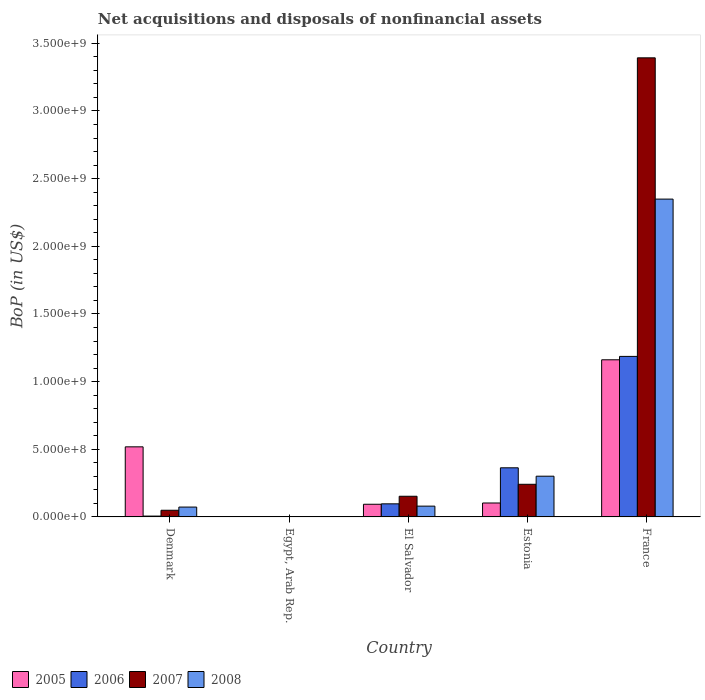Are the number of bars on each tick of the X-axis equal?
Keep it short and to the point. No. How many bars are there on the 5th tick from the left?
Your answer should be very brief. 4. How many bars are there on the 2nd tick from the right?
Offer a very short reply. 4. What is the label of the 3rd group of bars from the left?
Your answer should be compact. El Salvador. In how many cases, is the number of bars for a given country not equal to the number of legend labels?
Provide a short and direct response. 1. What is the Balance of Payments in 2005 in France?
Make the answer very short. 1.16e+09. Across all countries, what is the maximum Balance of Payments in 2007?
Offer a terse response. 3.39e+09. In which country was the Balance of Payments in 2006 maximum?
Give a very brief answer. France. What is the total Balance of Payments in 2006 in the graph?
Ensure brevity in your answer.  1.65e+09. What is the difference between the Balance of Payments in 2006 in Denmark and that in El Salvador?
Offer a very short reply. -9.05e+07. What is the difference between the Balance of Payments in 2005 in France and the Balance of Payments in 2007 in Egypt, Arab Rep.?
Your response must be concise. 1.16e+09. What is the average Balance of Payments in 2005 per country?
Provide a succinct answer. 3.75e+08. What is the difference between the Balance of Payments of/in 2008 and Balance of Payments of/in 2006 in France?
Make the answer very short. 1.16e+09. In how many countries, is the Balance of Payments in 2007 greater than 1900000000 US$?
Your response must be concise. 1. What is the ratio of the Balance of Payments in 2008 in El Salvador to that in Estonia?
Offer a terse response. 0.27. Is the Balance of Payments in 2006 in El Salvador less than that in France?
Ensure brevity in your answer.  Yes. Is the difference between the Balance of Payments in 2008 in Denmark and El Salvador greater than the difference between the Balance of Payments in 2006 in Denmark and El Salvador?
Your response must be concise. Yes. What is the difference between the highest and the second highest Balance of Payments in 2007?
Give a very brief answer. -3.24e+09. What is the difference between the highest and the lowest Balance of Payments in 2006?
Keep it short and to the point. 1.19e+09. In how many countries, is the Balance of Payments in 2008 greater than the average Balance of Payments in 2008 taken over all countries?
Make the answer very short. 1. Is the sum of the Balance of Payments in 2007 in Egypt, Arab Rep. and Estonia greater than the maximum Balance of Payments in 2005 across all countries?
Make the answer very short. No. Is it the case that in every country, the sum of the Balance of Payments in 2005 and Balance of Payments in 2006 is greater than the Balance of Payments in 2008?
Make the answer very short. No. Are all the bars in the graph horizontal?
Your answer should be very brief. No. How many countries are there in the graph?
Keep it short and to the point. 5. What is the difference between two consecutive major ticks on the Y-axis?
Provide a succinct answer. 5.00e+08. Where does the legend appear in the graph?
Your response must be concise. Bottom left. How many legend labels are there?
Provide a short and direct response. 4. What is the title of the graph?
Give a very brief answer. Net acquisitions and disposals of nonfinancial assets. What is the label or title of the X-axis?
Your answer should be very brief. Country. What is the label or title of the Y-axis?
Your answer should be compact. BoP (in US$). What is the BoP (in US$) in 2005 in Denmark?
Make the answer very short. 5.18e+08. What is the BoP (in US$) in 2006 in Denmark?
Make the answer very short. 6.28e+06. What is the BoP (in US$) of 2007 in Denmark?
Your answer should be compact. 4.93e+07. What is the BoP (in US$) in 2008 in Denmark?
Your answer should be compact. 7.29e+07. What is the BoP (in US$) in 2005 in Egypt, Arab Rep.?
Ensure brevity in your answer.  0. What is the BoP (in US$) in 2007 in Egypt, Arab Rep.?
Provide a succinct answer. 1.90e+06. What is the BoP (in US$) in 2005 in El Salvador?
Your response must be concise. 9.36e+07. What is the BoP (in US$) in 2006 in El Salvador?
Ensure brevity in your answer.  9.68e+07. What is the BoP (in US$) of 2007 in El Salvador?
Give a very brief answer. 1.53e+08. What is the BoP (in US$) of 2008 in El Salvador?
Provide a short and direct response. 7.98e+07. What is the BoP (in US$) in 2005 in Estonia?
Offer a terse response. 1.03e+08. What is the BoP (in US$) in 2006 in Estonia?
Provide a short and direct response. 3.63e+08. What is the BoP (in US$) in 2007 in Estonia?
Keep it short and to the point. 2.41e+08. What is the BoP (in US$) of 2008 in Estonia?
Your answer should be compact. 3.01e+08. What is the BoP (in US$) of 2005 in France?
Ensure brevity in your answer.  1.16e+09. What is the BoP (in US$) in 2006 in France?
Your response must be concise. 1.19e+09. What is the BoP (in US$) of 2007 in France?
Provide a succinct answer. 3.39e+09. What is the BoP (in US$) in 2008 in France?
Ensure brevity in your answer.  2.35e+09. Across all countries, what is the maximum BoP (in US$) of 2005?
Ensure brevity in your answer.  1.16e+09. Across all countries, what is the maximum BoP (in US$) in 2006?
Ensure brevity in your answer.  1.19e+09. Across all countries, what is the maximum BoP (in US$) in 2007?
Your answer should be very brief. 3.39e+09. Across all countries, what is the maximum BoP (in US$) of 2008?
Your answer should be very brief. 2.35e+09. Across all countries, what is the minimum BoP (in US$) of 2005?
Your response must be concise. 0. Across all countries, what is the minimum BoP (in US$) in 2006?
Your response must be concise. 0. Across all countries, what is the minimum BoP (in US$) in 2007?
Your response must be concise. 1.90e+06. Across all countries, what is the minimum BoP (in US$) of 2008?
Give a very brief answer. 0. What is the total BoP (in US$) in 2005 in the graph?
Your answer should be very brief. 1.88e+09. What is the total BoP (in US$) in 2006 in the graph?
Give a very brief answer. 1.65e+09. What is the total BoP (in US$) in 2007 in the graph?
Make the answer very short. 3.84e+09. What is the total BoP (in US$) in 2008 in the graph?
Your response must be concise. 2.80e+09. What is the difference between the BoP (in US$) of 2007 in Denmark and that in Egypt, Arab Rep.?
Ensure brevity in your answer.  4.74e+07. What is the difference between the BoP (in US$) of 2005 in Denmark and that in El Salvador?
Keep it short and to the point. 4.24e+08. What is the difference between the BoP (in US$) in 2006 in Denmark and that in El Salvador?
Keep it short and to the point. -9.05e+07. What is the difference between the BoP (in US$) of 2007 in Denmark and that in El Salvador?
Offer a very short reply. -1.03e+08. What is the difference between the BoP (in US$) in 2008 in Denmark and that in El Salvador?
Your answer should be compact. -6.95e+06. What is the difference between the BoP (in US$) in 2005 in Denmark and that in Estonia?
Your response must be concise. 4.15e+08. What is the difference between the BoP (in US$) in 2006 in Denmark and that in Estonia?
Make the answer very short. -3.57e+08. What is the difference between the BoP (in US$) in 2007 in Denmark and that in Estonia?
Your answer should be very brief. -1.92e+08. What is the difference between the BoP (in US$) in 2008 in Denmark and that in Estonia?
Provide a succinct answer. -2.28e+08. What is the difference between the BoP (in US$) in 2005 in Denmark and that in France?
Give a very brief answer. -6.43e+08. What is the difference between the BoP (in US$) in 2006 in Denmark and that in France?
Offer a very short reply. -1.18e+09. What is the difference between the BoP (in US$) in 2007 in Denmark and that in France?
Offer a very short reply. -3.34e+09. What is the difference between the BoP (in US$) of 2008 in Denmark and that in France?
Offer a terse response. -2.28e+09. What is the difference between the BoP (in US$) of 2007 in Egypt, Arab Rep. and that in El Salvador?
Make the answer very short. -1.51e+08. What is the difference between the BoP (in US$) in 2007 in Egypt, Arab Rep. and that in Estonia?
Provide a succinct answer. -2.39e+08. What is the difference between the BoP (in US$) of 2007 in Egypt, Arab Rep. and that in France?
Ensure brevity in your answer.  -3.39e+09. What is the difference between the BoP (in US$) of 2005 in El Salvador and that in Estonia?
Ensure brevity in your answer.  -9.37e+06. What is the difference between the BoP (in US$) in 2006 in El Salvador and that in Estonia?
Give a very brief answer. -2.66e+08. What is the difference between the BoP (in US$) of 2007 in El Salvador and that in Estonia?
Make the answer very short. -8.84e+07. What is the difference between the BoP (in US$) in 2008 in El Salvador and that in Estonia?
Give a very brief answer. -2.21e+08. What is the difference between the BoP (in US$) of 2005 in El Salvador and that in France?
Provide a succinct answer. -1.07e+09. What is the difference between the BoP (in US$) in 2006 in El Salvador and that in France?
Make the answer very short. -1.09e+09. What is the difference between the BoP (in US$) of 2007 in El Salvador and that in France?
Keep it short and to the point. -3.24e+09. What is the difference between the BoP (in US$) in 2008 in El Salvador and that in France?
Provide a short and direct response. -2.27e+09. What is the difference between the BoP (in US$) of 2005 in Estonia and that in France?
Your answer should be very brief. -1.06e+09. What is the difference between the BoP (in US$) in 2006 in Estonia and that in France?
Ensure brevity in your answer.  -8.23e+08. What is the difference between the BoP (in US$) in 2007 in Estonia and that in France?
Make the answer very short. -3.15e+09. What is the difference between the BoP (in US$) in 2008 in Estonia and that in France?
Ensure brevity in your answer.  -2.05e+09. What is the difference between the BoP (in US$) of 2005 in Denmark and the BoP (in US$) of 2007 in Egypt, Arab Rep.?
Make the answer very short. 5.16e+08. What is the difference between the BoP (in US$) of 2006 in Denmark and the BoP (in US$) of 2007 in Egypt, Arab Rep.?
Your answer should be compact. 4.38e+06. What is the difference between the BoP (in US$) of 2005 in Denmark and the BoP (in US$) of 2006 in El Salvador?
Offer a very short reply. 4.21e+08. What is the difference between the BoP (in US$) of 2005 in Denmark and the BoP (in US$) of 2007 in El Salvador?
Provide a succinct answer. 3.65e+08. What is the difference between the BoP (in US$) in 2005 in Denmark and the BoP (in US$) in 2008 in El Salvador?
Your response must be concise. 4.38e+08. What is the difference between the BoP (in US$) in 2006 in Denmark and the BoP (in US$) in 2007 in El Salvador?
Provide a short and direct response. -1.47e+08. What is the difference between the BoP (in US$) of 2006 in Denmark and the BoP (in US$) of 2008 in El Salvador?
Provide a short and direct response. -7.35e+07. What is the difference between the BoP (in US$) of 2007 in Denmark and the BoP (in US$) of 2008 in El Salvador?
Offer a very short reply. -3.05e+07. What is the difference between the BoP (in US$) of 2005 in Denmark and the BoP (in US$) of 2006 in Estonia?
Offer a very short reply. 1.55e+08. What is the difference between the BoP (in US$) of 2005 in Denmark and the BoP (in US$) of 2007 in Estonia?
Your answer should be very brief. 2.77e+08. What is the difference between the BoP (in US$) of 2005 in Denmark and the BoP (in US$) of 2008 in Estonia?
Your answer should be compact. 2.17e+08. What is the difference between the BoP (in US$) in 2006 in Denmark and the BoP (in US$) in 2007 in Estonia?
Provide a succinct answer. -2.35e+08. What is the difference between the BoP (in US$) in 2006 in Denmark and the BoP (in US$) in 2008 in Estonia?
Your answer should be very brief. -2.95e+08. What is the difference between the BoP (in US$) of 2007 in Denmark and the BoP (in US$) of 2008 in Estonia?
Your response must be concise. -2.52e+08. What is the difference between the BoP (in US$) of 2005 in Denmark and the BoP (in US$) of 2006 in France?
Ensure brevity in your answer.  -6.68e+08. What is the difference between the BoP (in US$) in 2005 in Denmark and the BoP (in US$) in 2007 in France?
Give a very brief answer. -2.87e+09. What is the difference between the BoP (in US$) of 2005 in Denmark and the BoP (in US$) of 2008 in France?
Offer a terse response. -1.83e+09. What is the difference between the BoP (in US$) of 2006 in Denmark and the BoP (in US$) of 2007 in France?
Your response must be concise. -3.39e+09. What is the difference between the BoP (in US$) in 2006 in Denmark and the BoP (in US$) in 2008 in France?
Give a very brief answer. -2.34e+09. What is the difference between the BoP (in US$) of 2007 in Denmark and the BoP (in US$) of 2008 in France?
Provide a short and direct response. -2.30e+09. What is the difference between the BoP (in US$) of 2007 in Egypt, Arab Rep. and the BoP (in US$) of 2008 in El Salvador?
Offer a terse response. -7.79e+07. What is the difference between the BoP (in US$) of 2007 in Egypt, Arab Rep. and the BoP (in US$) of 2008 in Estonia?
Provide a short and direct response. -2.99e+08. What is the difference between the BoP (in US$) in 2007 in Egypt, Arab Rep. and the BoP (in US$) in 2008 in France?
Provide a succinct answer. -2.35e+09. What is the difference between the BoP (in US$) of 2005 in El Salvador and the BoP (in US$) of 2006 in Estonia?
Offer a terse response. -2.69e+08. What is the difference between the BoP (in US$) in 2005 in El Salvador and the BoP (in US$) in 2007 in Estonia?
Provide a short and direct response. -1.48e+08. What is the difference between the BoP (in US$) of 2005 in El Salvador and the BoP (in US$) of 2008 in Estonia?
Ensure brevity in your answer.  -2.07e+08. What is the difference between the BoP (in US$) in 2006 in El Salvador and the BoP (in US$) in 2007 in Estonia?
Make the answer very short. -1.44e+08. What is the difference between the BoP (in US$) in 2006 in El Salvador and the BoP (in US$) in 2008 in Estonia?
Keep it short and to the point. -2.04e+08. What is the difference between the BoP (in US$) in 2007 in El Salvador and the BoP (in US$) in 2008 in Estonia?
Your answer should be very brief. -1.48e+08. What is the difference between the BoP (in US$) in 2005 in El Salvador and the BoP (in US$) in 2006 in France?
Offer a very short reply. -1.09e+09. What is the difference between the BoP (in US$) of 2005 in El Salvador and the BoP (in US$) of 2007 in France?
Keep it short and to the point. -3.30e+09. What is the difference between the BoP (in US$) in 2005 in El Salvador and the BoP (in US$) in 2008 in France?
Offer a very short reply. -2.26e+09. What is the difference between the BoP (in US$) of 2006 in El Salvador and the BoP (in US$) of 2007 in France?
Make the answer very short. -3.30e+09. What is the difference between the BoP (in US$) of 2006 in El Salvador and the BoP (in US$) of 2008 in France?
Ensure brevity in your answer.  -2.25e+09. What is the difference between the BoP (in US$) of 2007 in El Salvador and the BoP (in US$) of 2008 in France?
Provide a short and direct response. -2.20e+09. What is the difference between the BoP (in US$) in 2005 in Estonia and the BoP (in US$) in 2006 in France?
Ensure brevity in your answer.  -1.08e+09. What is the difference between the BoP (in US$) in 2005 in Estonia and the BoP (in US$) in 2007 in France?
Keep it short and to the point. -3.29e+09. What is the difference between the BoP (in US$) in 2005 in Estonia and the BoP (in US$) in 2008 in France?
Provide a succinct answer. -2.25e+09. What is the difference between the BoP (in US$) in 2006 in Estonia and the BoP (in US$) in 2007 in France?
Your response must be concise. -3.03e+09. What is the difference between the BoP (in US$) in 2006 in Estonia and the BoP (in US$) in 2008 in France?
Offer a very short reply. -1.99e+09. What is the difference between the BoP (in US$) in 2007 in Estonia and the BoP (in US$) in 2008 in France?
Offer a terse response. -2.11e+09. What is the average BoP (in US$) of 2005 per country?
Your answer should be compact. 3.75e+08. What is the average BoP (in US$) in 2006 per country?
Ensure brevity in your answer.  3.30e+08. What is the average BoP (in US$) of 2007 per country?
Your answer should be compact. 7.68e+08. What is the average BoP (in US$) of 2008 per country?
Make the answer very short. 5.61e+08. What is the difference between the BoP (in US$) in 2005 and BoP (in US$) in 2006 in Denmark?
Ensure brevity in your answer.  5.12e+08. What is the difference between the BoP (in US$) of 2005 and BoP (in US$) of 2007 in Denmark?
Your response must be concise. 4.69e+08. What is the difference between the BoP (in US$) in 2005 and BoP (in US$) in 2008 in Denmark?
Give a very brief answer. 4.45e+08. What is the difference between the BoP (in US$) in 2006 and BoP (in US$) in 2007 in Denmark?
Ensure brevity in your answer.  -4.30e+07. What is the difference between the BoP (in US$) in 2006 and BoP (in US$) in 2008 in Denmark?
Offer a terse response. -6.66e+07. What is the difference between the BoP (in US$) in 2007 and BoP (in US$) in 2008 in Denmark?
Provide a short and direct response. -2.35e+07. What is the difference between the BoP (in US$) of 2005 and BoP (in US$) of 2006 in El Salvador?
Give a very brief answer. -3.20e+06. What is the difference between the BoP (in US$) of 2005 and BoP (in US$) of 2007 in El Salvador?
Give a very brief answer. -5.92e+07. What is the difference between the BoP (in US$) of 2005 and BoP (in US$) of 2008 in El Salvador?
Keep it short and to the point. 1.38e+07. What is the difference between the BoP (in US$) in 2006 and BoP (in US$) in 2007 in El Salvador?
Your answer should be very brief. -5.60e+07. What is the difference between the BoP (in US$) in 2006 and BoP (in US$) in 2008 in El Salvador?
Offer a very short reply. 1.70e+07. What is the difference between the BoP (in US$) in 2007 and BoP (in US$) in 2008 in El Salvador?
Your response must be concise. 7.30e+07. What is the difference between the BoP (in US$) in 2005 and BoP (in US$) in 2006 in Estonia?
Offer a terse response. -2.60e+08. What is the difference between the BoP (in US$) in 2005 and BoP (in US$) in 2007 in Estonia?
Provide a succinct answer. -1.38e+08. What is the difference between the BoP (in US$) of 2005 and BoP (in US$) of 2008 in Estonia?
Your answer should be very brief. -1.98e+08. What is the difference between the BoP (in US$) of 2006 and BoP (in US$) of 2007 in Estonia?
Provide a succinct answer. 1.22e+08. What is the difference between the BoP (in US$) of 2006 and BoP (in US$) of 2008 in Estonia?
Your answer should be very brief. 6.19e+07. What is the difference between the BoP (in US$) of 2007 and BoP (in US$) of 2008 in Estonia?
Offer a terse response. -5.99e+07. What is the difference between the BoP (in US$) of 2005 and BoP (in US$) of 2006 in France?
Provide a succinct answer. -2.51e+07. What is the difference between the BoP (in US$) in 2005 and BoP (in US$) in 2007 in France?
Keep it short and to the point. -2.23e+09. What is the difference between the BoP (in US$) of 2005 and BoP (in US$) of 2008 in France?
Offer a very short reply. -1.19e+09. What is the difference between the BoP (in US$) of 2006 and BoP (in US$) of 2007 in France?
Your response must be concise. -2.21e+09. What is the difference between the BoP (in US$) in 2006 and BoP (in US$) in 2008 in France?
Offer a very short reply. -1.16e+09. What is the difference between the BoP (in US$) in 2007 and BoP (in US$) in 2008 in France?
Keep it short and to the point. 1.04e+09. What is the ratio of the BoP (in US$) in 2007 in Denmark to that in Egypt, Arab Rep.?
Offer a very short reply. 25.95. What is the ratio of the BoP (in US$) in 2005 in Denmark to that in El Salvador?
Ensure brevity in your answer.  5.53. What is the ratio of the BoP (in US$) of 2006 in Denmark to that in El Salvador?
Make the answer very short. 0.06. What is the ratio of the BoP (in US$) in 2007 in Denmark to that in El Salvador?
Provide a short and direct response. 0.32. What is the ratio of the BoP (in US$) of 2008 in Denmark to that in El Salvador?
Make the answer very short. 0.91. What is the ratio of the BoP (in US$) of 2005 in Denmark to that in Estonia?
Keep it short and to the point. 5.03. What is the ratio of the BoP (in US$) of 2006 in Denmark to that in Estonia?
Offer a very short reply. 0.02. What is the ratio of the BoP (in US$) of 2007 in Denmark to that in Estonia?
Provide a short and direct response. 0.2. What is the ratio of the BoP (in US$) in 2008 in Denmark to that in Estonia?
Your answer should be compact. 0.24. What is the ratio of the BoP (in US$) in 2005 in Denmark to that in France?
Provide a succinct answer. 0.45. What is the ratio of the BoP (in US$) of 2006 in Denmark to that in France?
Provide a succinct answer. 0.01. What is the ratio of the BoP (in US$) of 2007 in Denmark to that in France?
Keep it short and to the point. 0.01. What is the ratio of the BoP (in US$) in 2008 in Denmark to that in France?
Offer a very short reply. 0.03. What is the ratio of the BoP (in US$) in 2007 in Egypt, Arab Rep. to that in El Salvador?
Provide a short and direct response. 0.01. What is the ratio of the BoP (in US$) of 2007 in Egypt, Arab Rep. to that in Estonia?
Provide a succinct answer. 0.01. What is the ratio of the BoP (in US$) of 2007 in Egypt, Arab Rep. to that in France?
Provide a short and direct response. 0. What is the ratio of the BoP (in US$) in 2005 in El Salvador to that in Estonia?
Ensure brevity in your answer.  0.91. What is the ratio of the BoP (in US$) in 2006 in El Salvador to that in Estonia?
Your answer should be compact. 0.27. What is the ratio of the BoP (in US$) of 2007 in El Salvador to that in Estonia?
Make the answer very short. 0.63. What is the ratio of the BoP (in US$) of 2008 in El Salvador to that in Estonia?
Your answer should be compact. 0.27. What is the ratio of the BoP (in US$) of 2005 in El Salvador to that in France?
Offer a very short reply. 0.08. What is the ratio of the BoP (in US$) in 2006 in El Salvador to that in France?
Ensure brevity in your answer.  0.08. What is the ratio of the BoP (in US$) of 2007 in El Salvador to that in France?
Your answer should be compact. 0.04. What is the ratio of the BoP (in US$) in 2008 in El Salvador to that in France?
Offer a very short reply. 0.03. What is the ratio of the BoP (in US$) of 2005 in Estonia to that in France?
Offer a very short reply. 0.09. What is the ratio of the BoP (in US$) of 2006 in Estonia to that in France?
Provide a short and direct response. 0.31. What is the ratio of the BoP (in US$) of 2007 in Estonia to that in France?
Offer a terse response. 0.07. What is the ratio of the BoP (in US$) of 2008 in Estonia to that in France?
Ensure brevity in your answer.  0.13. What is the difference between the highest and the second highest BoP (in US$) in 2005?
Your answer should be compact. 6.43e+08. What is the difference between the highest and the second highest BoP (in US$) of 2006?
Offer a very short reply. 8.23e+08. What is the difference between the highest and the second highest BoP (in US$) of 2007?
Offer a terse response. 3.15e+09. What is the difference between the highest and the second highest BoP (in US$) in 2008?
Keep it short and to the point. 2.05e+09. What is the difference between the highest and the lowest BoP (in US$) in 2005?
Your answer should be very brief. 1.16e+09. What is the difference between the highest and the lowest BoP (in US$) of 2006?
Provide a short and direct response. 1.19e+09. What is the difference between the highest and the lowest BoP (in US$) in 2007?
Your answer should be compact. 3.39e+09. What is the difference between the highest and the lowest BoP (in US$) in 2008?
Your response must be concise. 2.35e+09. 